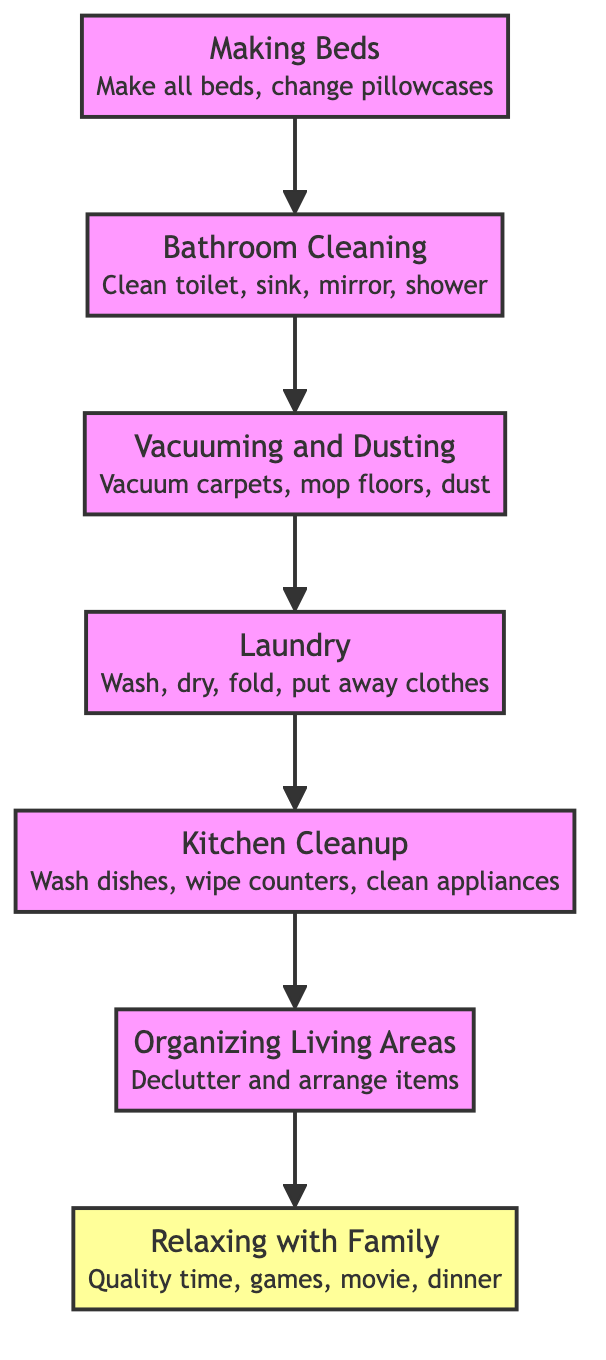What's the final activity in the flow chart? The flow chart starts from "Making Beds" and ends with "Relaxing with Family," which is the topmost node.
Answer: Relaxing with Family What comes immediately before Laundry in the sequence? In the flow of the diagram, Laundry follows Vacuuming and Dusting, which is the node before it in the flow.
Answer: Vacuuming and Dusting How many total activities are represented in the flow chart? The diagram lists 7 activities in total, from "Making Beds" to "Relaxing with Family."
Answer: 7 What type of activity is "Bathroom Cleaning"? "Bathroom Cleaning" is one of the tasks in the cleaning process, which is evident by its position within the sequence of chores performed leading to relaxing.
Answer: Cleaning What is the relationship between "Kitchen Cleanup" and "Organizing Living Areas"? "Kitchen Cleanup" leads to "Organizing Living Areas," indicating that completing kitchen chores is necessary before organizing living spaces.
Answer: Precedes What activity is directly linked to "Making Beds"? The flow shows that "Making Beds" connects directly to "Bathroom Cleaning," indicating that this is the first step in the chore sequence.
Answer: Bathroom Cleaning Which activity allows for family relaxation at the top of the chart? The final result of all chores performed is "Relaxing with Family," representing quality time after completing all activities.
Answer: Relaxing with Family What must be done after "Laundry" before moving on to "Kitchen Cleanup"? After finishing "Laundry," the next step outlined in the flow is "Kitchen Cleanup," indicating the sequence of chores must be followed.
Answer: Kitchen Cleanup What is the sequential order of chores from start to finish? Starting from the bottom, the order is "Making Beds," "Bathroom Cleaning," "Vacuuming and Dusting," "Laundry," "Kitchen Cleanup," "Organizing Living Areas," and finally "Relaxing with Family."
Answer: Making Beds, Bathroom Cleaning, Vacuuming and Dusting, Laundry, Kitchen Cleanup, Organizing Living Areas, Relaxing with Family 